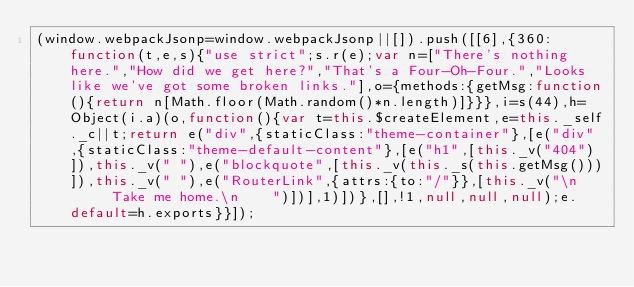Convert code to text. <code><loc_0><loc_0><loc_500><loc_500><_JavaScript_>(window.webpackJsonp=window.webpackJsonp||[]).push([[6],{360:function(t,e,s){"use strict";s.r(e);var n=["There's nothing here.","How did we get here?","That's a Four-Oh-Four.","Looks like we've got some broken links."],o={methods:{getMsg:function(){return n[Math.floor(Math.random()*n.length)]}}},i=s(44),h=Object(i.a)(o,function(){var t=this.$createElement,e=this._self._c||t;return e("div",{staticClass:"theme-container"},[e("div",{staticClass:"theme-default-content"},[e("h1",[this._v("404")]),this._v(" "),e("blockquote",[this._v(this._s(this.getMsg()))]),this._v(" "),e("RouterLink",{attrs:{to:"/"}},[this._v("\n      Take me home.\n    ")])],1)])},[],!1,null,null,null);e.default=h.exports}}]);</code> 